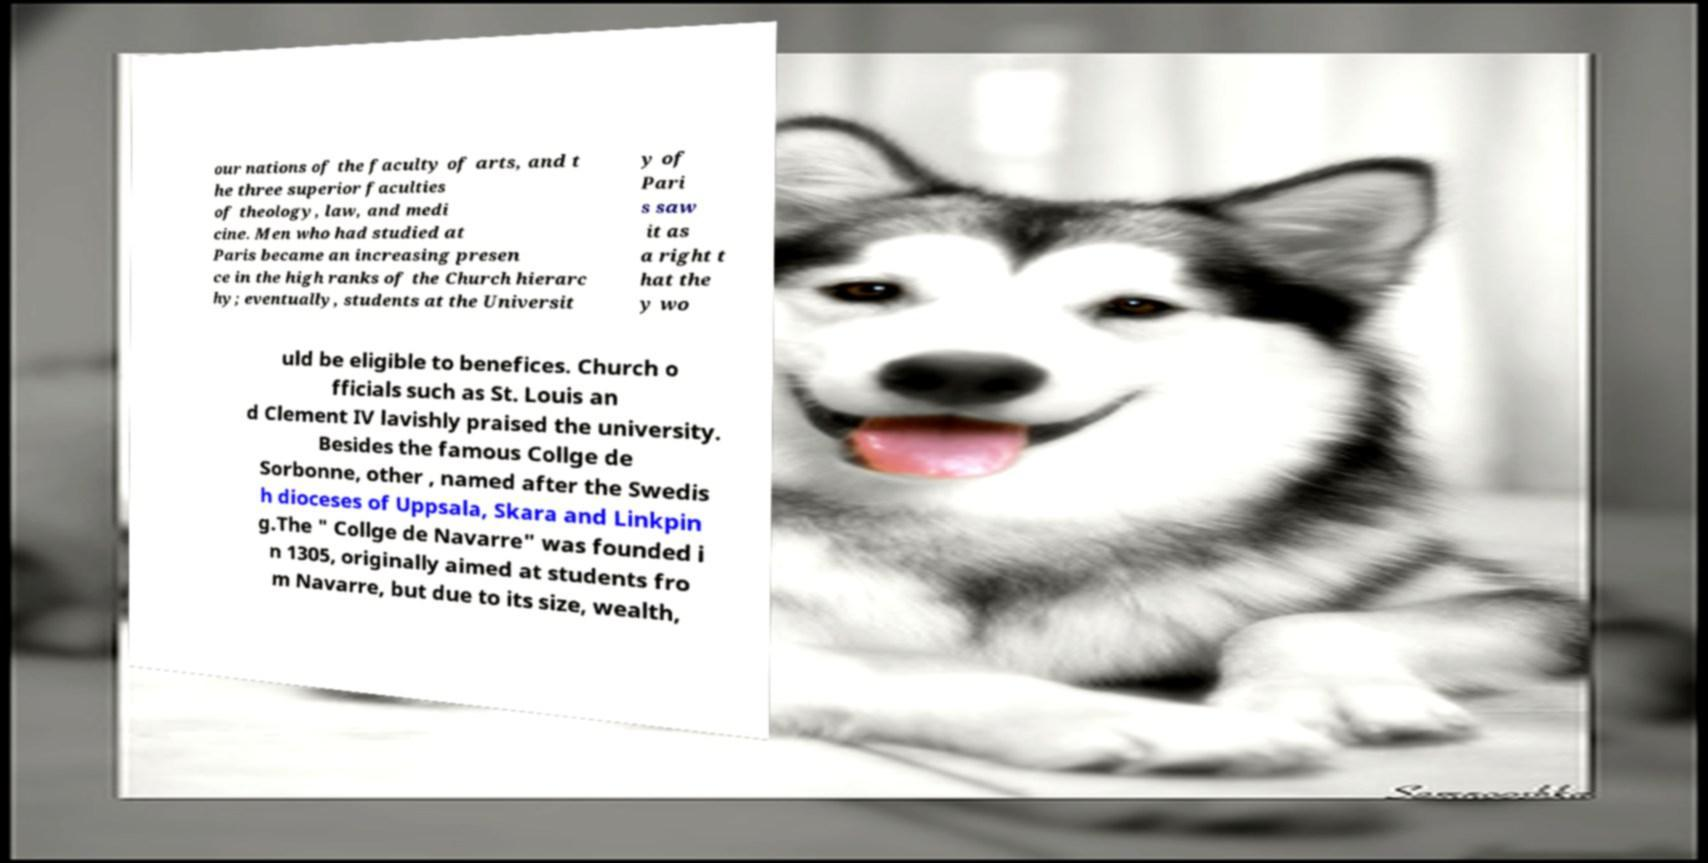Please read and relay the text visible in this image. What does it say? our nations of the faculty of arts, and t he three superior faculties of theology, law, and medi cine. Men who had studied at Paris became an increasing presen ce in the high ranks of the Church hierarc hy; eventually, students at the Universit y of Pari s saw it as a right t hat the y wo uld be eligible to benefices. Church o fficials such as St. Louis an d Clement IV lavishly praised the university. Besides the famous Collge de Sorbonne, other , named after the Swedis h dioceses of Uppsala, Skara and Linkpin g.The " Collge de Navarre" was founded i n 1305, originally aimed at students fro m Navarre, but due to its size, wealth, 